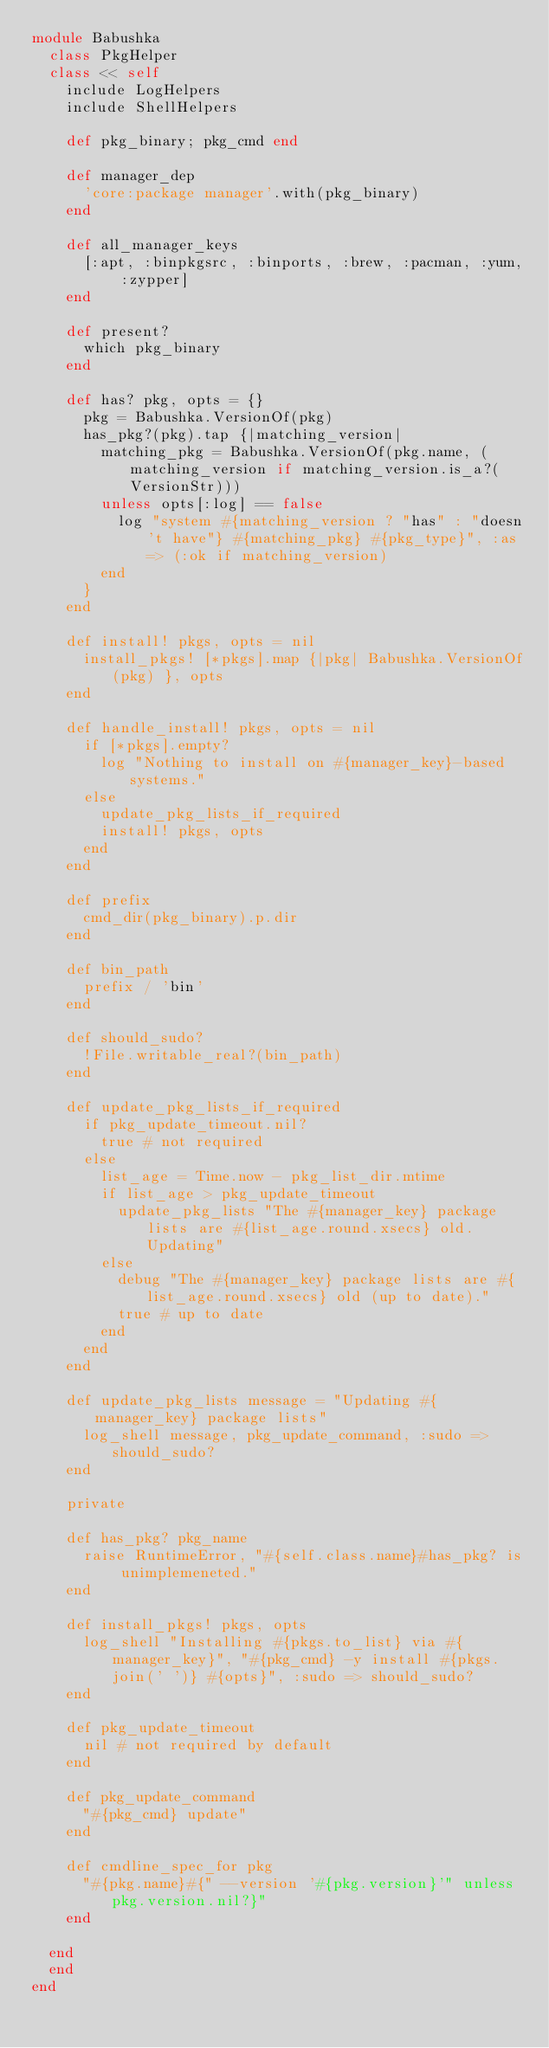Convert code to text. <code><loc_0><loc_0><loc_500><loc_500><_Ruby_>module Babushka
  class PkgHelper
  class << self
    include LogHelpers
    include ShellHelpers

    def pkg_binary; pkg_cmd end

    def manager_dep
      'core:package manager'.with(pkg_binary)
    end

    def all_manager_keys
      [:apt, :binpkgsrc, :binports, :brew, :pacman, :yum, :zypper]
    end

    def present?
      which pkg_binary
    end

    def has? pkg, opts = {}
      pkg = Babushka.VersionOf(pkg)
      has_pkg?(pkg).tap {|matching_version|
        matching_pkg = Babushka.VersionOf(pkg.name, (matching_version if matching_version.is_a?(VersionStr)))
        unless opts[:log] == false
          log "system #{matching_version ? "has" : "doesn't have"} #{matching_pkg} #{pkg_type}", :as => (:ok if matching_version)
        end
      }
    end

    def install! pkgs, opts = nil
      install_pkgs! [*pkgs].map {|pkg| Babushka.VersionOf(pkg) }, opts
    end

    def handle_install! pkgs, opts = nil
      if [*pkgs].empty?
        log "Nothing to install on #{manager_key}-based systems."
      else
        update_pkg_lists_if_required
        install! pkgs, opts
      end
    end

    def prefix
      cmd_dir(pkg_binary).p.dir
    end

    def bin_path
      prefix / 'bin'
    end

    def should_sudo?
      !File.writable_real?(bin_path)
    end

    def update_pkg_lists_if_required
      if pkg_update_timeout.nil?
        true # not required
      else
        list_age = Time.now - pkg_list_dir.mtime
        if list_age > pkg_update_timeout
          update_pkg_lists "The #{manager_key} package lists are #{list_age.round.xsecs} old. Updating"
        else
          debug "The #{manager_key} package lists are #{list_age.round.xsecs} old (up to date)."
          true # up to date
        end
      end
    end

    def update_pkg_lists message = "Updating #{manager_key} package lists"
      log_shell message, pkg_update_command, :sudo => should_sudo?
    end

    private

    def has_pkg? pkg_name
      raise RuntimeError, "#{self.class.name}#has_pkg? is unimplemeneted."
    end

    def install_pkgs! pkgs, opts
      log_shell "Installing #{pkgs.to_list} via #{manager_key}", "#{pkg_cmd} -y install #{pkgs.join(' ')} #{opts}", :sudo => should_sudo?
    end

    def pkg_update_timeout
      nil # not required by default
    end

    def pkg_update_command
      "#{pkg_cmd} update"
    end

    def cmdline_spec_for pkg
      "#{pkg.name}#{" --version '#{pkg.version}'" unless pkg.version.nil?}"
    end

  end
  end
end
</code> 